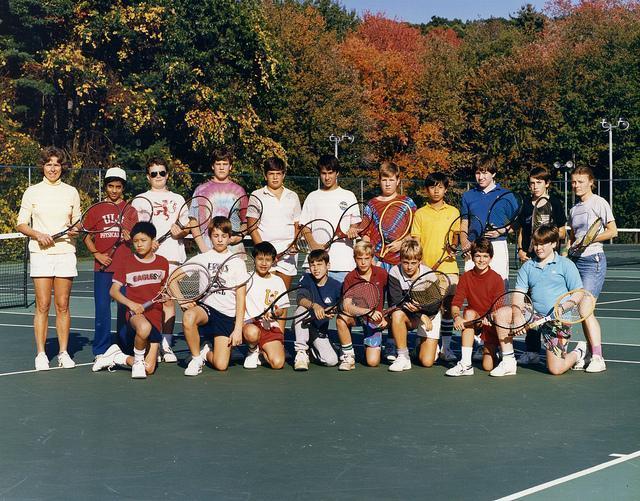How many women are in this scene?
Give a very brief answer. 2. How many people are there?
Give a very brief answer. 14. 